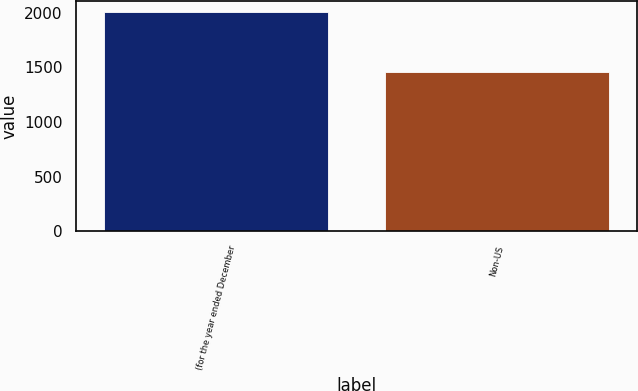Convert chart to OTSL. <chart><loc_0><loc_0><loc_500><loc_500><bar_chart><fcel>(for the year ended December<fcel>Non-US<nl><fcel>2005<fcel>1457<nl></chart> 